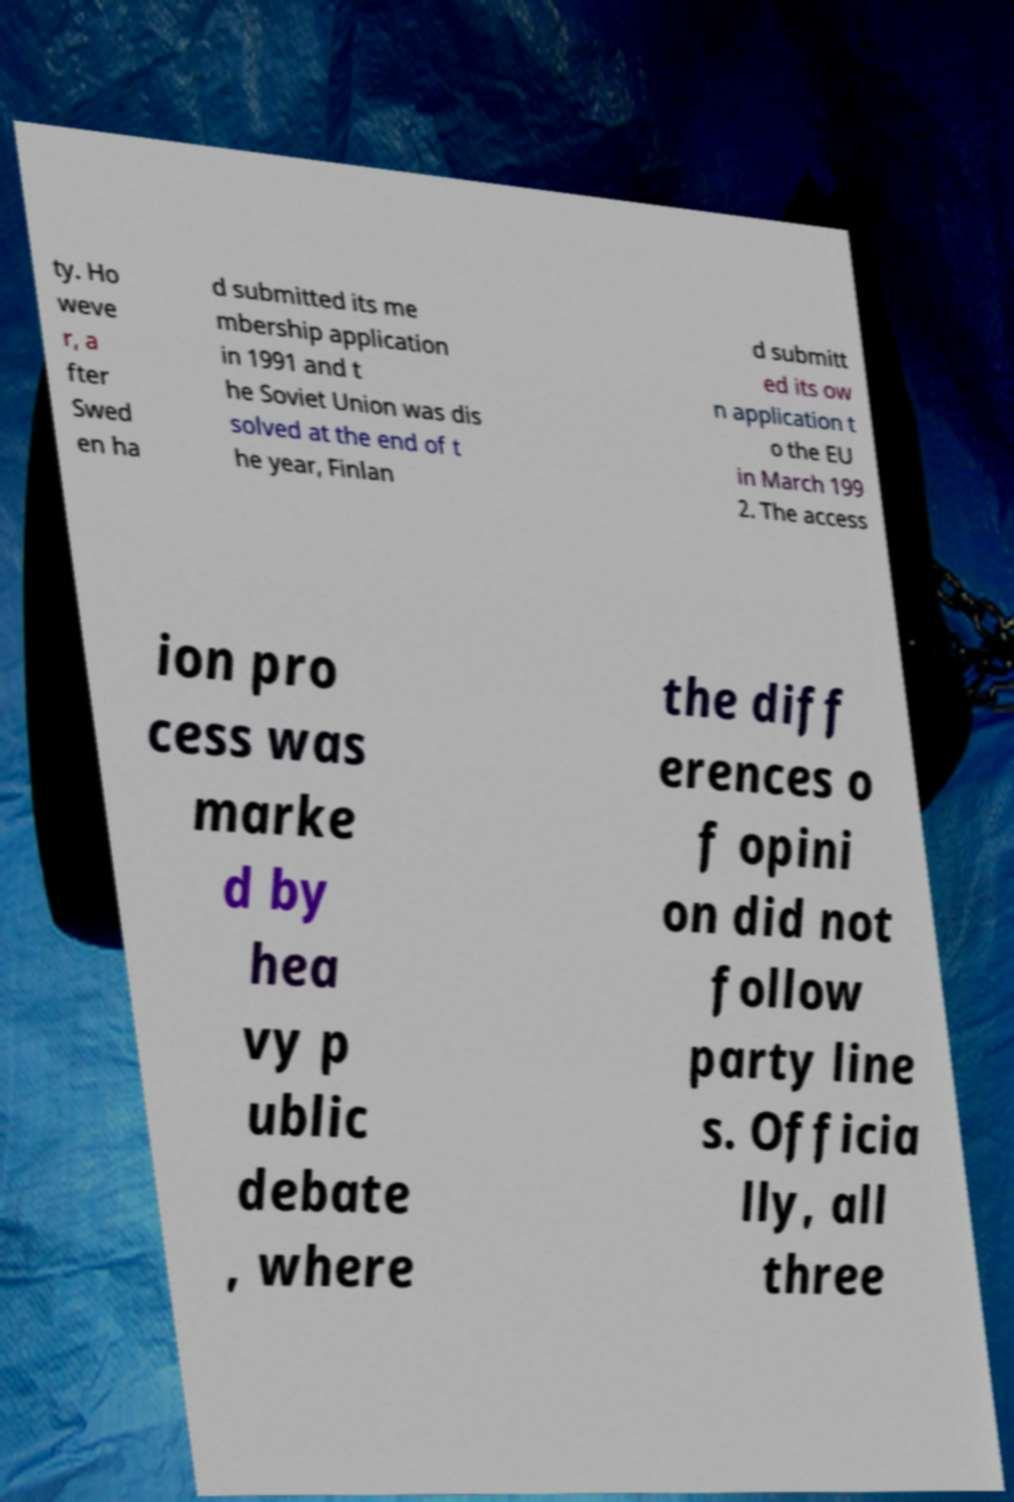Please identify and transcribe the text found in this image. ty. Ho weve r, a fter Swed en ha d submitted its me mbership application in 1991 and t he Soviet Union was dis solved at the end of t he year, Finlan d submitt ed its ow n application t o the EU in March 199 2. The access ion pro cess was marke d by hea vy p ublic debate , where the diff erences o f opini on did not follow party line s. Officia lly, all three 